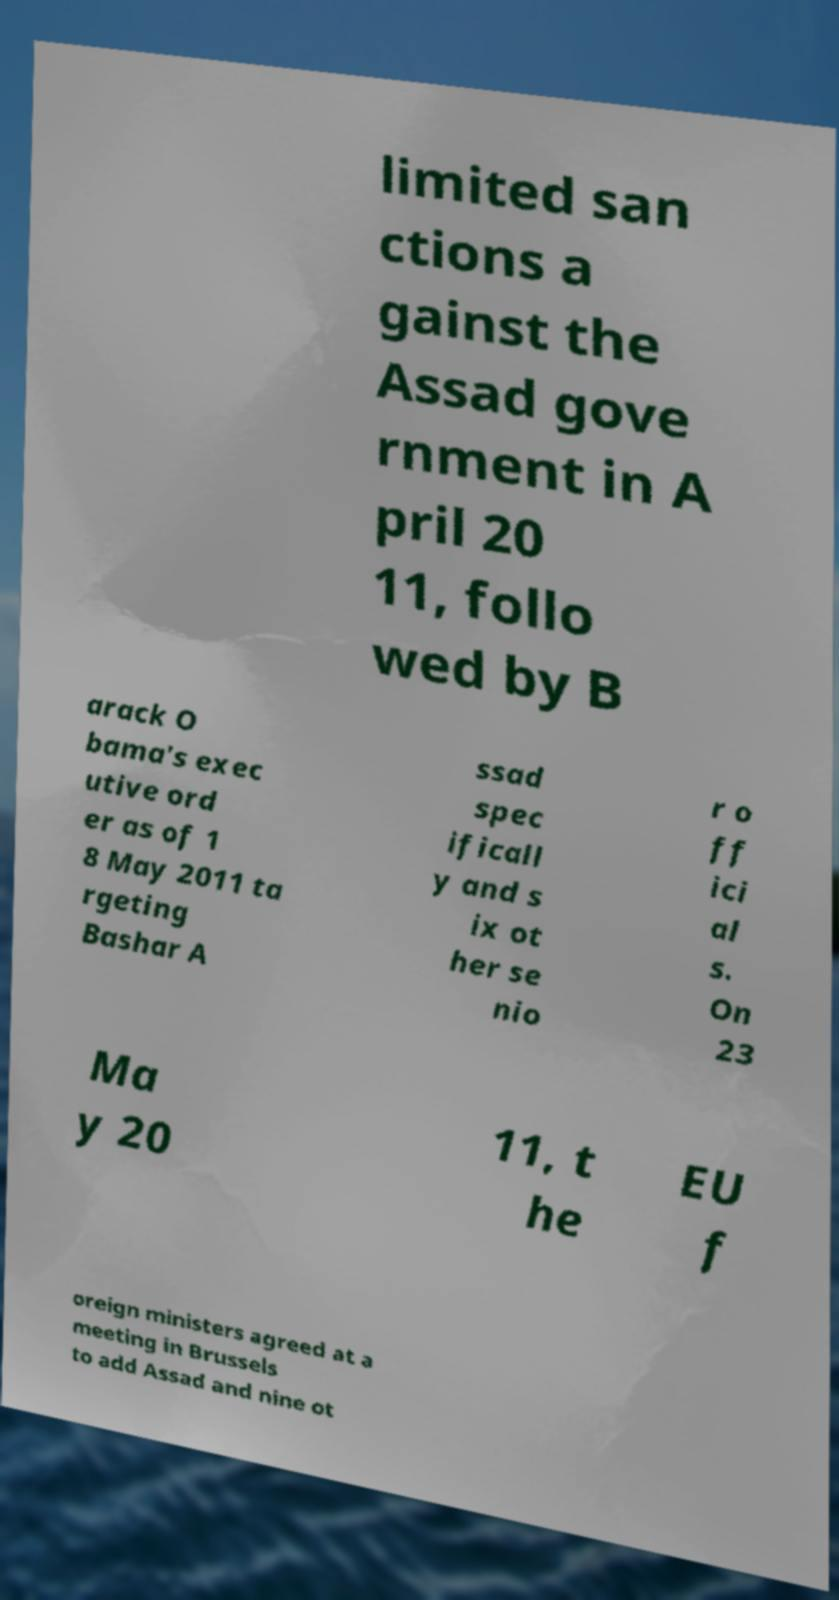For documentation purposes, I need the text within this image transcribed. Could you provide that? limited san ctions a gainst the Assad gove rnment in A pril 20 11, follo wed by B arack O bama's exec utive ord er as of 1 8 May 2011 ta rgeting Bashar A ssad spec ificall y and s ix ot her se nio r o ff ici al s. On 23 Ma y 20 11, t he EU f oreign ministers agreed at a meeting in Brussels to add Assad and nine ot 